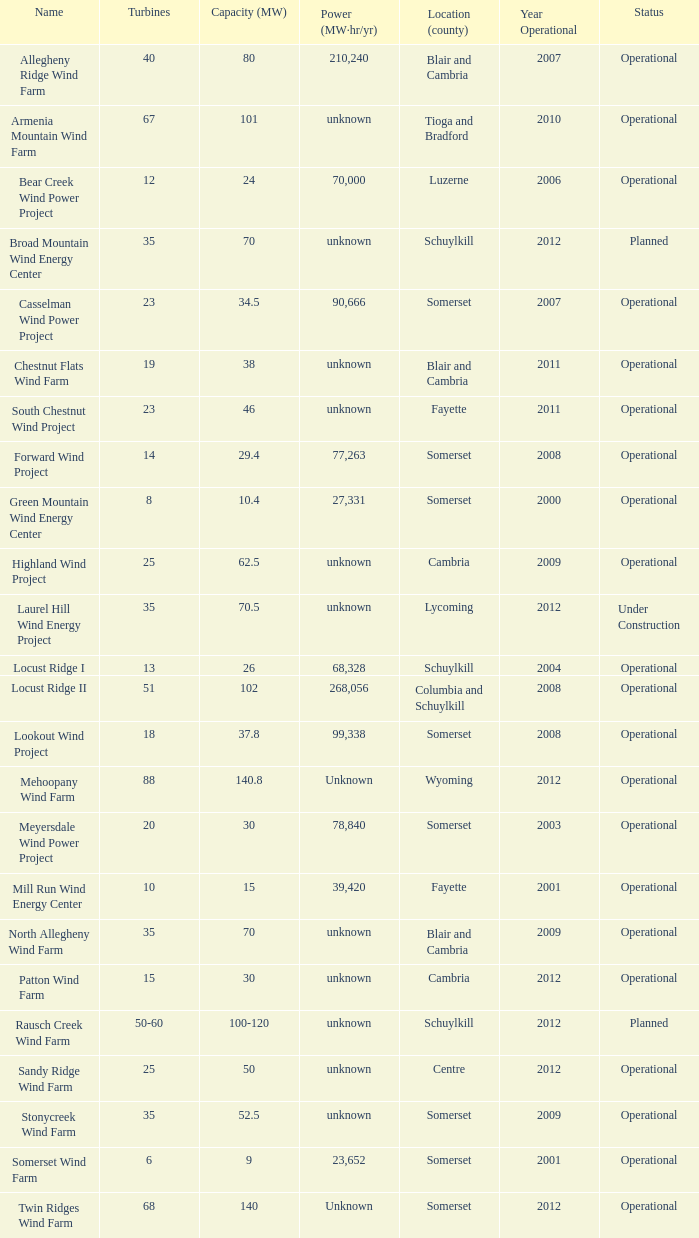Which farm with a capacity of 70 is currently functioning? North Allegheny Wind Farm. Write the full table. {'header': ['Name', 'Turbines', 'Capacity (MW)', 'Power (MW·hr/yr)', 'Location (county)', 'Year Operational', 'Status'], 'rows': [['Allegheny Ridge Wind Farm', '40', '80', '210,240', 'Blair and Cambria', '2007', 'Operational'], ['Armenia Mountain Wind Farm', '67', '101', 'unknown', 'Tioga and Bradford', '2010', 'Operational'], ['Bear Creek Wind Power Project', '12', '24', '70,000', 'Luzerne', '2006', 'Operational'], ['Broad Mountain Wind Energy Center', '35', '70', 'unknown', 'Schuylkill', '2012', 'Planned'], ['Casselman Wind Power Project', '23', '34.5', '90,666', 'Somerset', '2007', 'Operational'], ['Chestnut Flats Wind Farm', '19', '38', 'unknown', 'Blair and Cambria', '2011', 'Operational'], ['South Chestnut Wind Project', '23', '46', 'unknown', 'Fayette', '2011', 'Operational'], ['Forward Wind Project', '14', '29.4', '77,263', 'Somerset', '2008', 'Operational'], ['Green Mountain Wind Energy Center', '8', '10.4', '27,331', 'Somerset', '2000', 'Operational'], ['Highland Wind Project', '25', '62.5', 'unknown', 'Cambria', '2009', 'Operational'], ['Laurel Hill Wind Energy Project', '35', '70.5', 'unknown', 'Lycoming', '2012', 'Under Construction'], ['Locust Ridge I', '13', '26', '68,328', 'Schuylkill', '2004', 'Operational'], ['Locust Ridge II', '51', '102', '268,056', 'Columbia and Schuylkill', '2008', 'Operational'], ['Lookout Wind Project', '18', '37.8', '99,338', 'Somerset', '2008', 'Operational'], ['Mehoopany Wind Farm', '88', '140.8', 'Unknown', 'Wyoming', '2012', 'Operational'], ['Meyersdale Wind Power Project', '20', '30', '78,840', 'Somerset', '2003', 'Operational'], ['Mill Run Wind Energy Center', '10', '15', '39,420', 'Fayette', '2001', 'Operational'], ['North Allegheny Wind Farm', '35', '70', 'unknown', 'Blair and Cambria', '2009', 'Operational'], ['Patton Wind Farm', '15', '30', 'unknown', 'Cambria', '2012', 'Operational'], ['Rausch Creek Wind Farm', '50-60', '100-120', 'unknown', 'Schuylkill', '2012', 'Planned'], ['Sandy Ridge Wind Farm', '25', '50', 'unknown', 'Centre', '2012', 'Operational'], ['Stonycreek Wind Farm', '35', '52.5', 'unknown', 'Somerset', '2009', 'Operational'], ['Somerset Wind Farm', '6', '9', '23,652', 'Somerset', '2001', 'Operational'], ['Twin Ridges Wind Farm', '68', '140', 'Unknown', 'Somerset', '2012', 'Operational']]} 